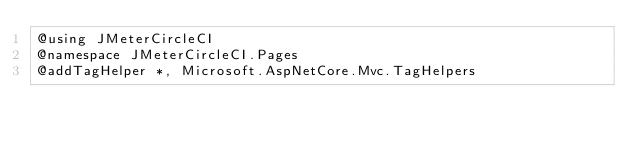<code> <loc_0><loc_0><loc_500><loc_500><_C#_>@using JMeterCircleCI
@namespace JMeterCircleCI.Pages
@addTagHelper *, Microsoft.AspNetCore.Mvc.TagHelpers
</code> 